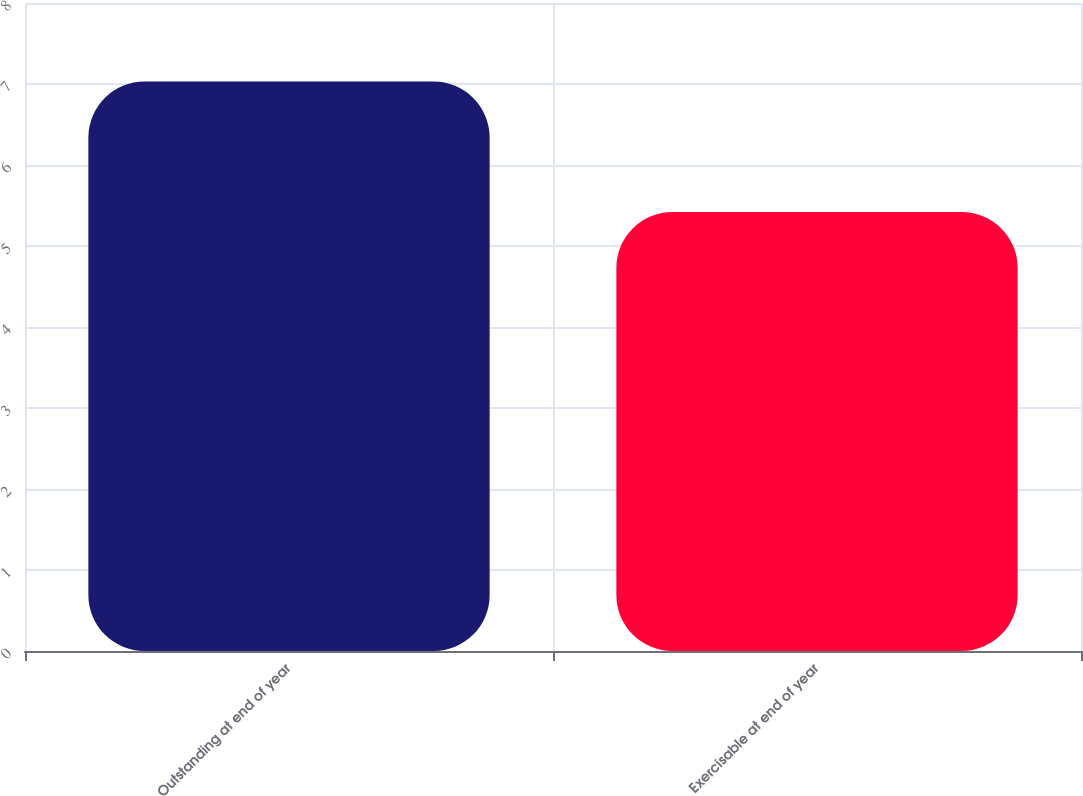Convert chart. <chart><loc_0><loc_0><loc_500><loc_500><bar_chart><fcel>Outstanding at end of year<fcel>Exercisable at end of year<nl><fcel>7.03<fcel>5.42<nl></chart> 